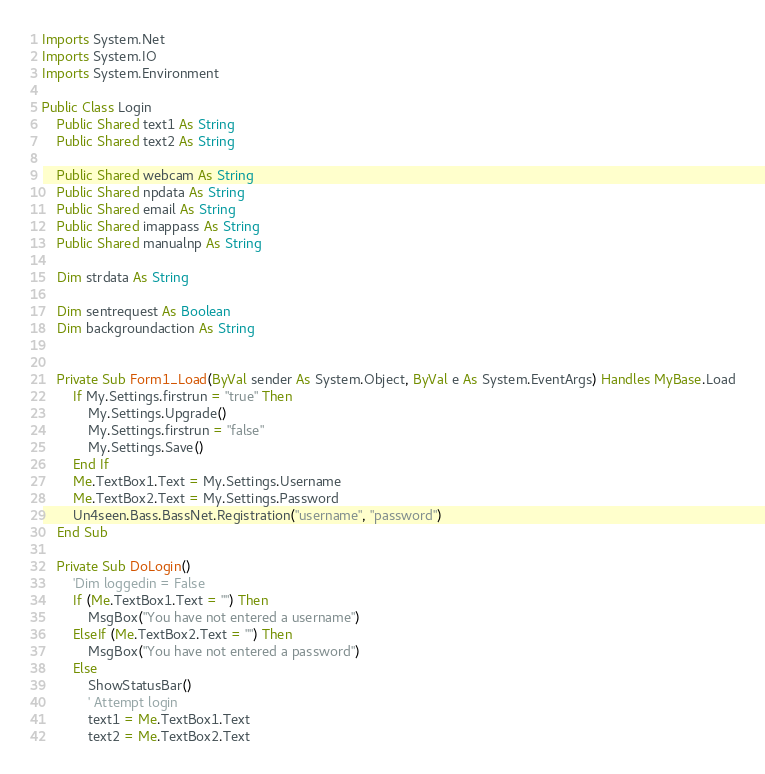<code> <loc_0><loc_0><loc_500><loc_500><_VisualBasic_>
Imports System.Net
Imports System.IO
Imports System.Environment

Public Class Login
    Public Shared text1 As String
    Public Shared text2 As String

    Public Shared webcam As String
    Public Shared npdata As String
    Public Shared email As String
    Public Shared imappass As String
    Public Shared manualnp As String

    Dim strdata As String

    Dim sentrequest As Boolean
    Dim backgroundaction As String


    Private Sub Form1_Load(ByVal sender As System.Object, ByVal e As System.EventArgs) Handles MyBase.Load
        If My.Settings.firstrun = "true" Then
            My.Settings.Upgrade()
            My.Settings.firstrun = "false"
            My.Settings.Save()
        End If
        Me.TextBox1.Text = My.Settings.Username
        Me.TextBox2.Text = My.Settings.Password
        Un4seen.Bass.BassNet.Registration("username", "password")
    End Sub

    Private Sub DoLogin()
        'Dim loggedin = False
        If (Me.TextBox1.Text = "") Then
            MsgBox("You have not entered a username")
        ElseIf (Me.TextBox2.Text = "") Then
            MsgBox("You have not entered a password")
        Else
            ShowStatusBar()
            ' Attempt login
            text1 = Me.TextBox1.Text
            text2 = Me.TextBox2.Text</code> 